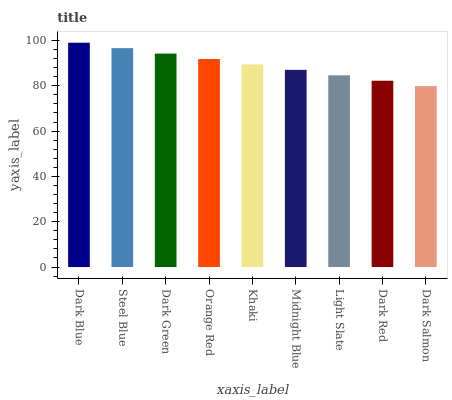Is Dark Salmon the minimum?
Answer yes or no. Yes. Is Dark Blue the maximum?
Answer yes or no. Yes. Is Steel Blue the minimum?
Answer yes or no. No. Is Steel Blue the maximum?
Answer yes or no. No. Is Dark Blue greater than Steel Blue?
Answer yes or no. Yes. Is Steel Blue less than Dark Blue?
Answer yes or no. Yes. Is Steel Blue greater than Dark Blue?
Answer yes or no. No. Is Dark Blue less than Steel Blue?
Answer yes or no. No. Is Khaki the high median?
Answer yes or no. Yes. Is Khaki the low median?
Answer yes or no. Yes. Is Dark Salmon the high median?
Answer yes or no. No. Is Orange Red the low median?
Answer yes or no. No. 